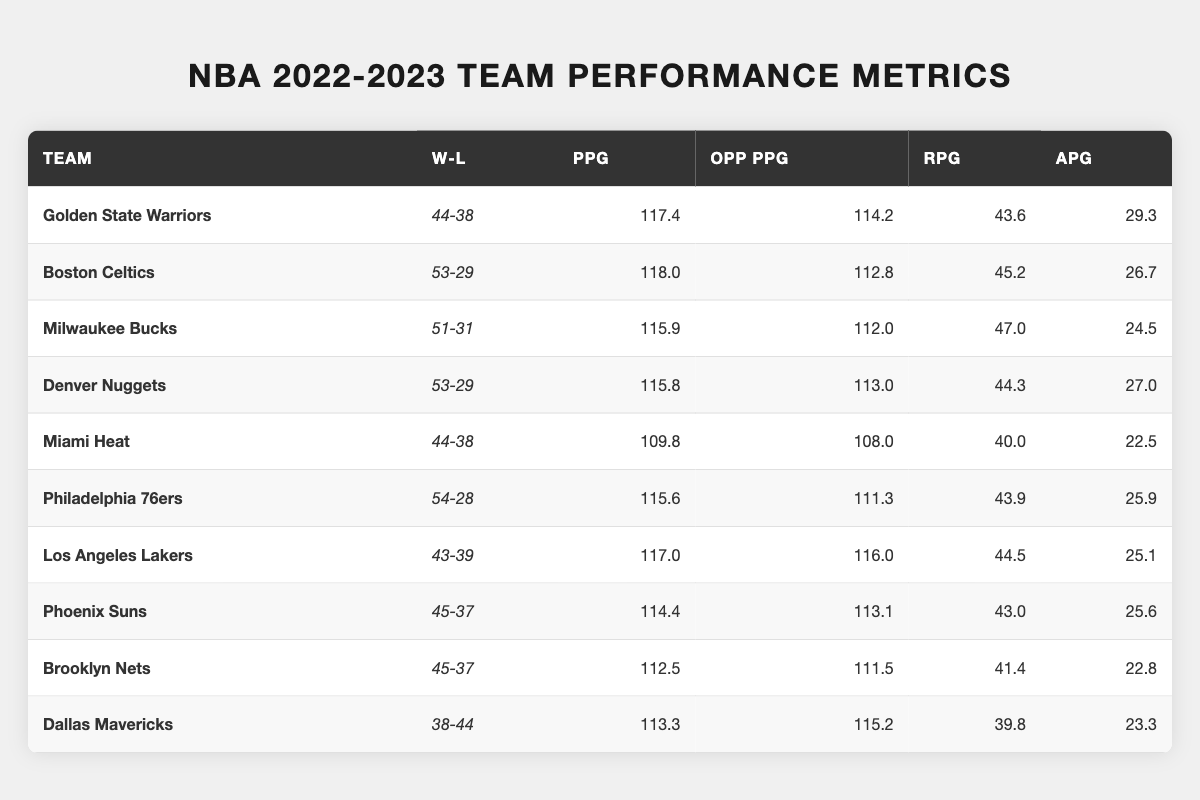What team had the highest points per game? To find the highest points per game, we can look through the "PPG" column in the table. The Boston Celtics score 118.0 points per game, which is the highest value recorded.
Answer: Boston Celtics What is the win-loss record of the Milwaukee Bucks? The win-loss record for the Milwaukee Bucks is provided directly in the "W-L" column, which shows 51 wins and 31 losses.
Answer: 51-31 Which team had the most assists per game? By checking the "APG" column in the table, we see that the Golden State Warriors have the highest number of assists per game at 29.3.
Answer: Golden State Warriors What is the difference in wins between the Boston Celtics and the Golden State Warriors? The Boston Celtics have 53 wins, while the Golden State Warriors have 44 wins. The difference is calculated as 53 - 44 = 9.
Answer: 9 Did the Miami Heat allow more points per game than they scored? To answer this, we compare the "PPG" (109.8) against the "Opp PPG" (108.0) for the Miami Heat. Since 109.8 points scored is greater than 108.0 points allowed, the answer is no.
Answer: No What is the average points per game for the top three teams? The top three teams based on points per game are the Boston Celtics (118.0), Denver Nuggets (115.8), and Philadelphia 76ers (115.6). Adding these gives 118.0 + 115.8 + 115.6 = 349.4. The average is then 349.4 divided by 3, which equals approximately 116.47.
Answer: 116.47 Which two teams had the same number of wins? Checking the wins column reveals that both the Miami Heat and the Golden State Warriors have the same win count of 44.
Answer: Miami Heat and Golden State Warriors What is the total rebounds per game for all teams? We need to sum the "RPG" column's values: 43.6 + 45.2 + 47.0 + 44.3 + 40.0 + 43.9 + 44.5 + 43.0 + 41.4 + 39.8 =  429.7.
Answer: 429.7 Was the Los Angeles Lakers' points allowed greater than their points scored? For the Los Angeles Lakers, the "PPG" is 117.0 and the "Opp PPG" is 116.0. Since 116.0 (points allowed) is less than 117.0 (points scored), the answer is no.
Answer: No Which team had the lowest assists per game among all listed teams? Looking through the "APG" column, the team with the lowest assists per game is the Miami Heat at 22.5 assists per game.
Answer: Miami Heat What is the win-loss record of the team that scored the fewest points per game? The team with the fewest points per game is the Miami Heat, with a win-loss record of 44-38, as indicated in the "W-L" column.
Answer: 44-38 